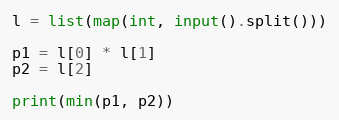Convert code to text. <code><loc_0><loc_0><loc_500><loc_500><_Python_>
l = list(map(int, input().split()))

p1 = l[0] * l[1]
p2 = l[2]

print(min(p1, p2))</code> 